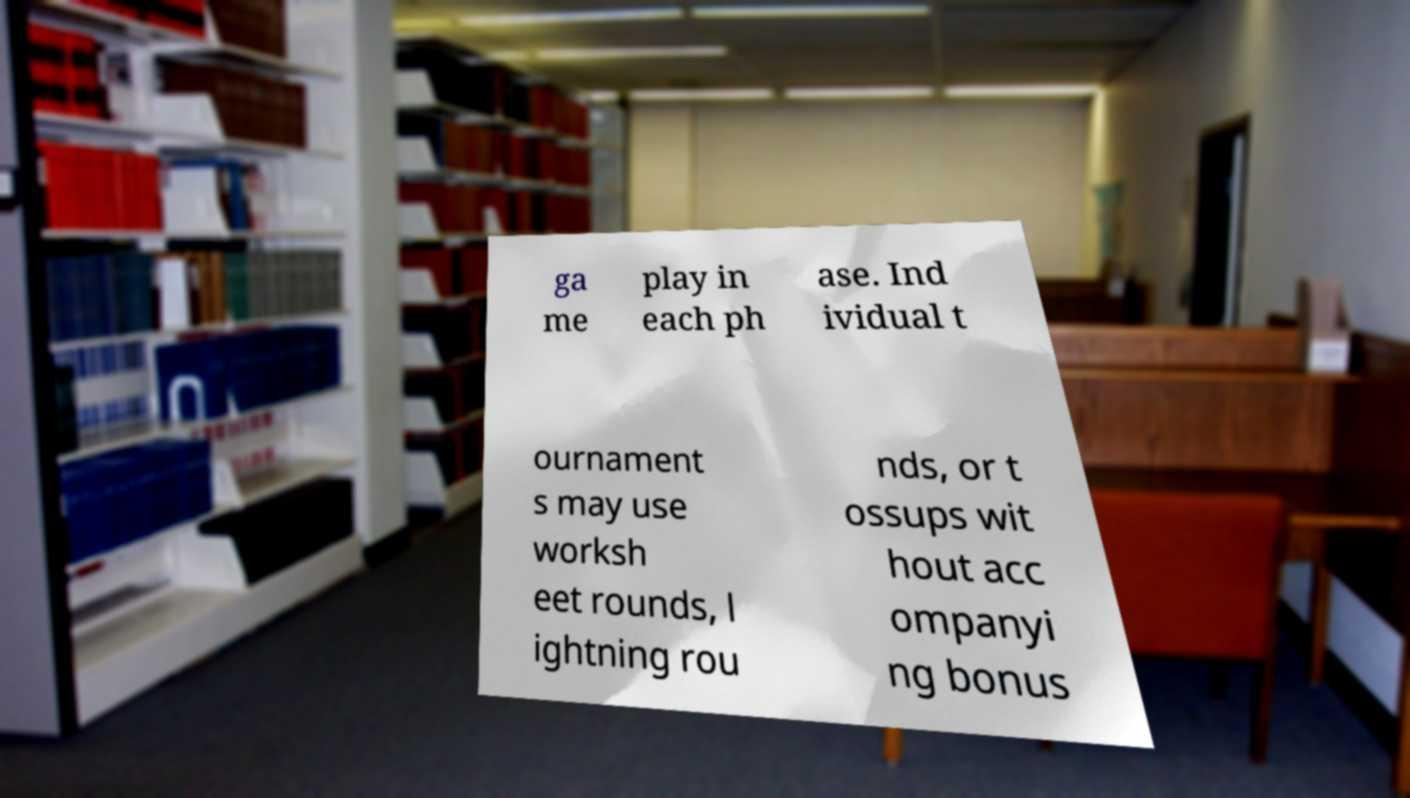Could you assist in decoding the text presented in this image and type it out clearly? ga me play in each ph ase. Ind ividual t ournament s may use worksh eet rounds, l ightning rou nds, or t ossups wit hout acc ompanyi ng bonus 